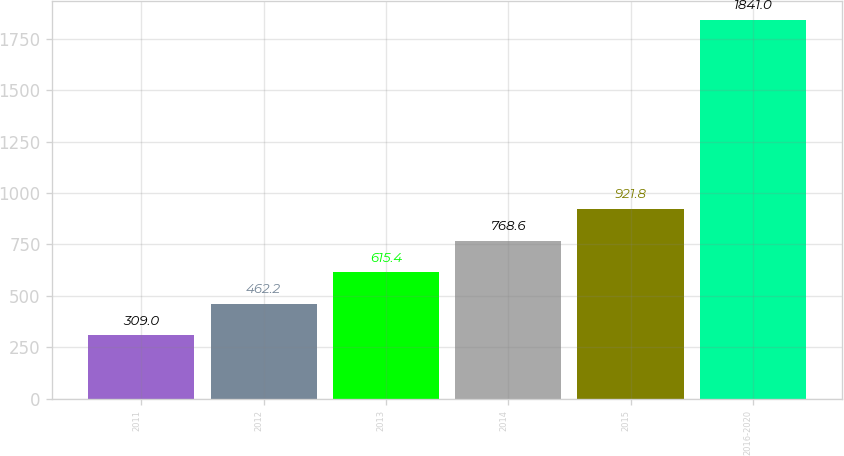Convert chart to OTSL. <chart><loc_0><loc_0><loc_500><loc_500><bar_chart><fcel>2011<fcel>2012<fcel>2013<fcel>2014<fcel>2015<fcel>2016-2020<nl><fcel>309<fcel>462.2<fcel>615.4<fcel>768.6<fcel>921.8<fcel>1841<nl></chart> 